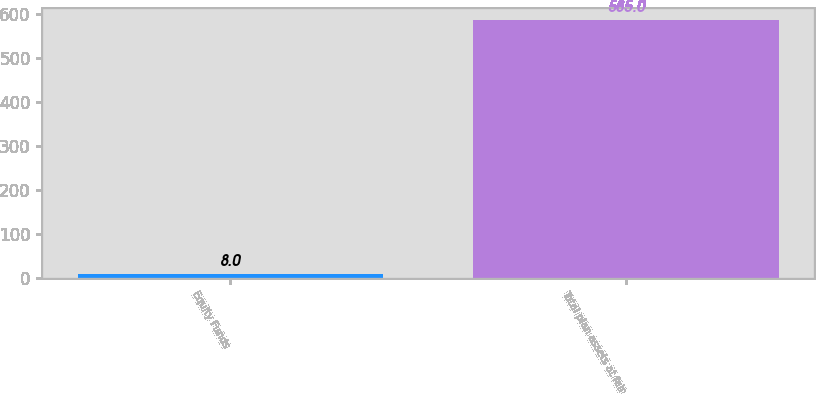<chart> <loc_0><loc_0><loc_500><loc_500><bar_chart><fcel>Equity Funds<fcel>Total plan assets at fair<nl><fcel>8<fcel>585<nl></chart> 